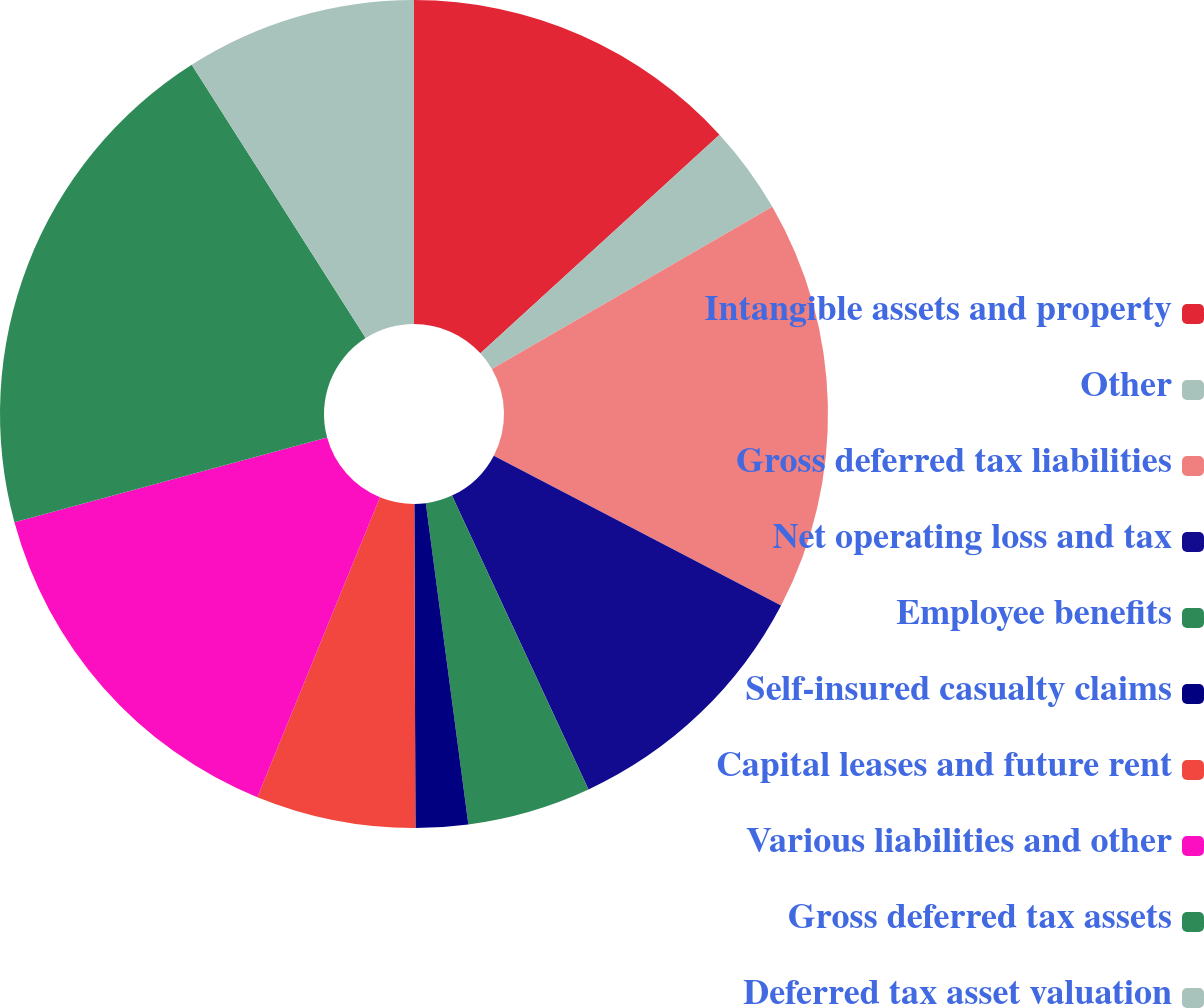Convert chart to OTSL. <chart><loc_0><loc_0><loc_500><loc_500><pie_chart><fcel>Intangible assets and property<fcel>Other<fcel>Gross deferred tax liabilities<fcel>Net operating loss and tax<fcel>Employee benefits<fcel>Self-insured casualty claims<fcel>Capital leases and future rent<fcel>Various liabilities and other<fcel>Gross deferred tax assets<fcel>Deferred tax asset valuation<nl><fcel>13.21%<fcel>3.44%<fcel>16.0%<fcel>10.42%<fcel>4.83%<fcel>2.04%<fcel>6.23%<fcel>14.61%<fcel>20.19%<fcel>9.02%<nl></chart> 